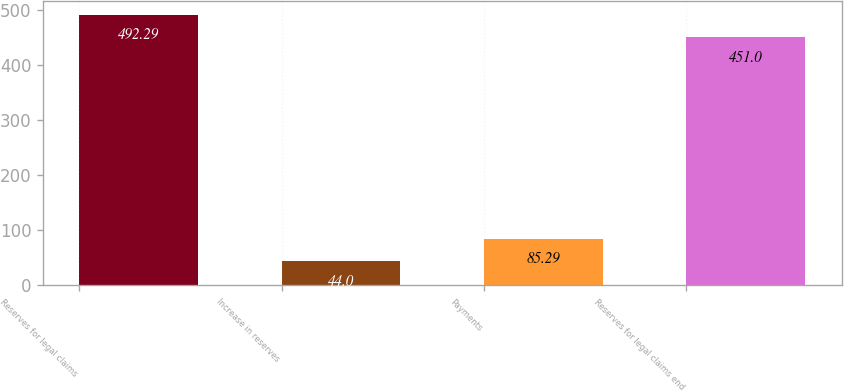Convert chart. <chart><loc_0><loc_0><loc_500><loc_500><bar_chart><fcel>Reserves for legal claims<fcel>Increase in reserves<fcel>Payments<fcel>Reserves for legal claims end<nl><fcel>492.29<fcel>44<fcel>85.29<fcel>451<nl></chart> 